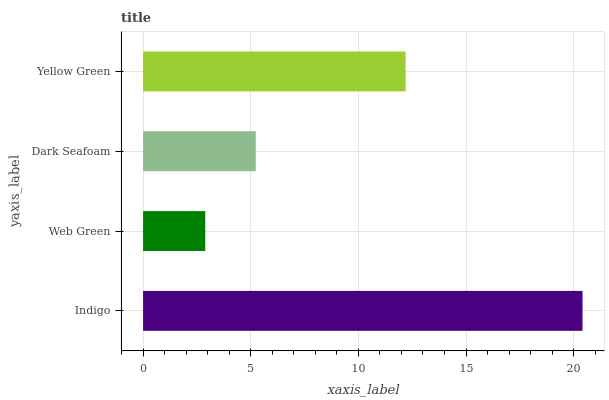Is Web Green the minimum?
Answer yes or no. Yes. Is Indigo the maximum?
Answer yes or no. Yes. Is Dark Seafoam the minimum?
Answer yes or no. No. Is Dark Seafoam the maximum?
Answer yes or no. No. Is Dark Seafoam greater than Web Green?
Answer yes or no. Yes. Is Web Green less than Dark Seafoam?
Answer yes or no. Yes. Is Web Green greater than Dark Seafoam?
Answer yes or no. No. Is Dark Seafoam less than Web Green?
Answer yes or no. No. Is Yellow Green the high median?
Answer yes or no. Yes. Is Dark Seafoam the low median?
Answer yes or no. Yes. Is Indigo the high median?
Answer yes or no. No. Is Indigo the low median?
Answer yes or no. No. 